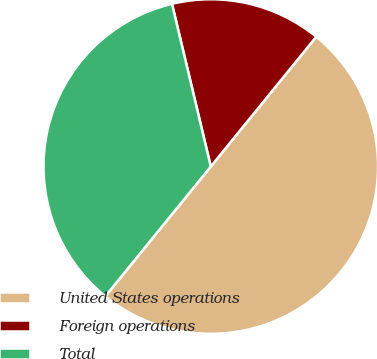<chart> <loc_0><loc_0><loc_500><loc_500><pie_chart><fcel>United States operations<fcel>Foreign operations<fcel>Total<nl><fcel>50.0%<fcel>14.59%<fcel>35.41%<nl></chart> 